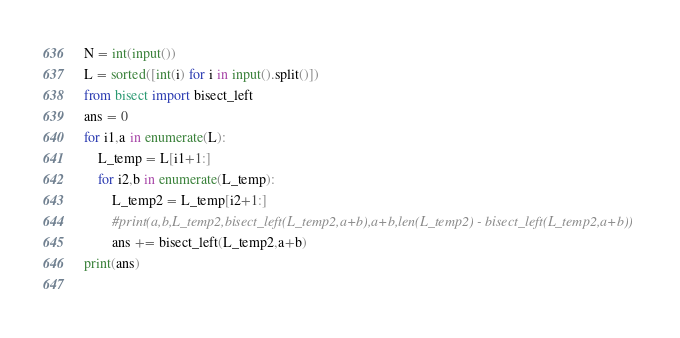<code> <loc_0><loc_0><loc_500><loc_500><_Python_>N = int(input())
L = sorted([int(i) for i in input().split()])
from bisect import bisect_left
ans = 0
for i1,a in enumerate(L):
    L_temp = L[i1+1:]
    for i2,b in enumerate(L_temp):
        L_temp2 = L_temp[i2+1:]
        #print(a,b,L_temp2,bisect_left(L_temp2,a+b),a+b,len(L_temp2) - bisect_left(L_temp2,a+b))
        ans += bisect_left(L_temp2,a+b)
print(ans)
            </code> 